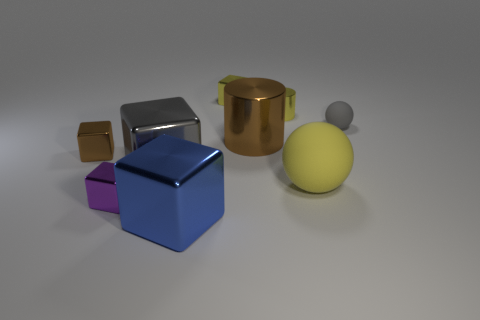Subtract all purple blocks. How many blocks are left? 4 Subtract all purple cubes. How many cubes are left? 4 Subtract all red blocks. Subtract all blue cylinders. How many blocks are left? 5 Add 1 blue cubes. How many objects exist? 10 Subtract all cubes. How many objects are left? 4 Add 4 spheres. How many spheres are left? 6 Add 1 green matte blocks. How many green matte blocks exist? 1 Subtract 1 yellow balls. How many objects are left? 8 Subtract all large cyan matte cylinders. Subtract all brown cylinders. How many objects are left? 8 